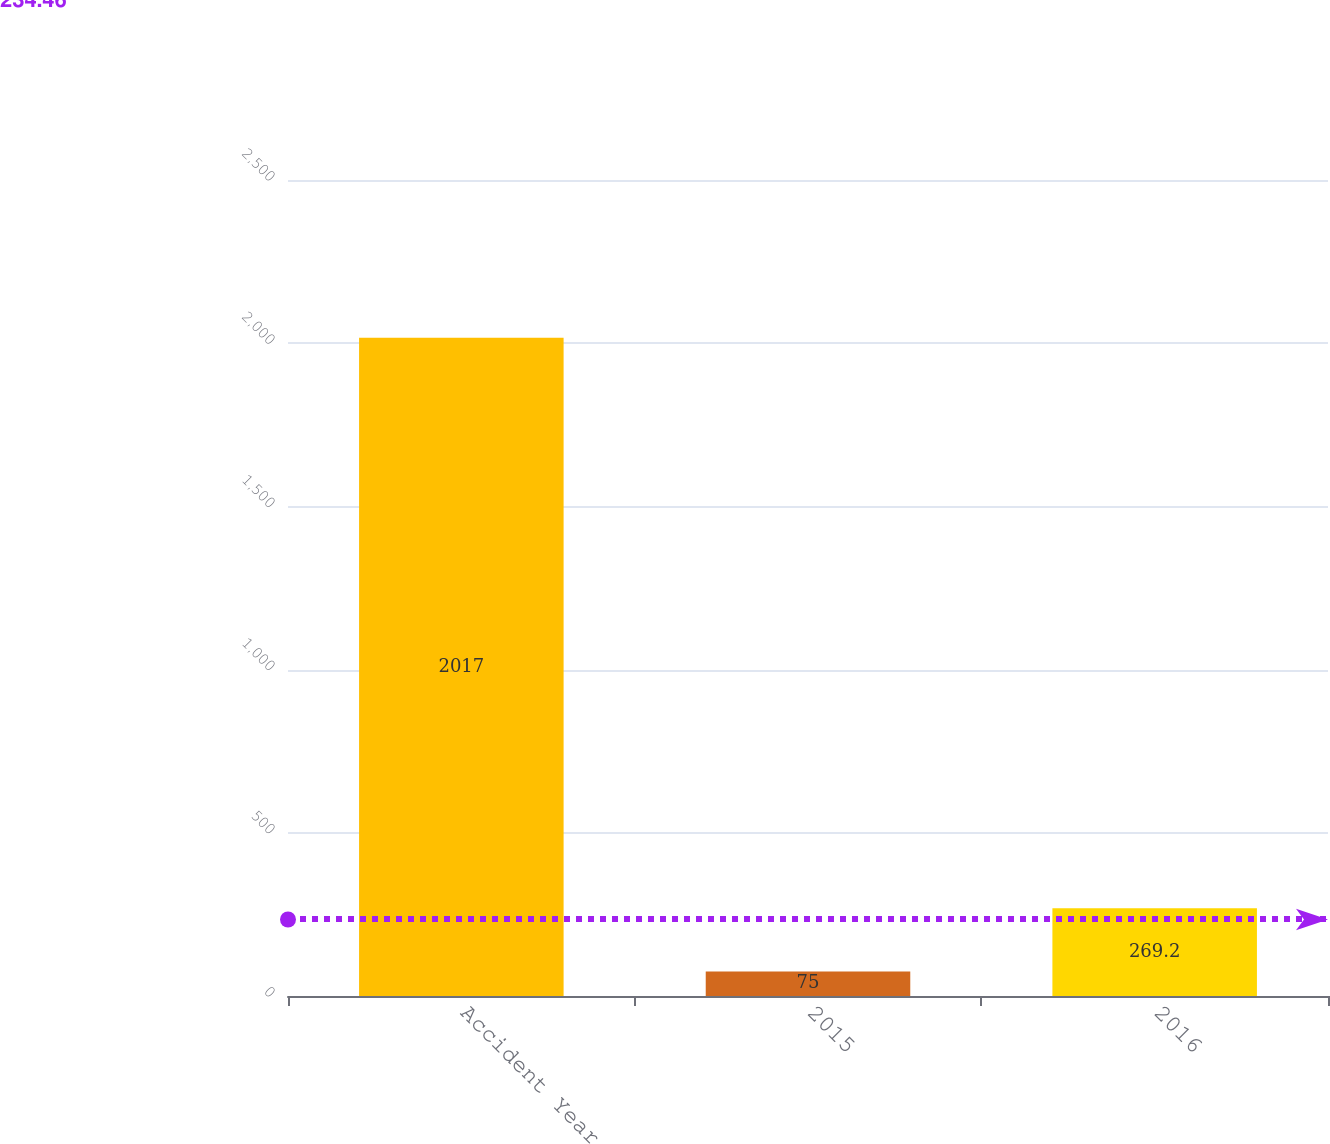Convert chart to OTSL. <chart><loc_0><loc_0><loc_500><loc_500><bar_chart><fcel>Accident Year<fcel>2015<fcel>2016<nl><fcel>2017<fcel>75<fcel>269.2<nl></chart> 